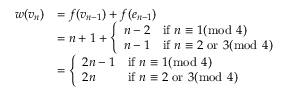Convert formula to latex. <formula><loc_0><loc_0><loc_500><loc_500>\begin{array} { r l } { w ( v _ { n } ) } & { = f ( v _ { n - 1 } ) + f ( e _ { n - 1 } ) } \\ & { = n + 1 + \left \{ \begin{array} { l l } { n - 2 } & { i f n \equiv 1 ( \bmod 4 ) } \\ { n - 1 } & { i f n \equiv 2 o r 3 ( \bmod 4 ) } \end{array} } \\ & { = \left \{ \begin{array} { l l } { 2 n - 1 } & { i f n \equiv 1 ( \bmod 4 ) } \\ { 2 n } & { i f n \equiv 2 o r 3 ( \bmod 4 ) } \end{array} } \end{array}</formula> 